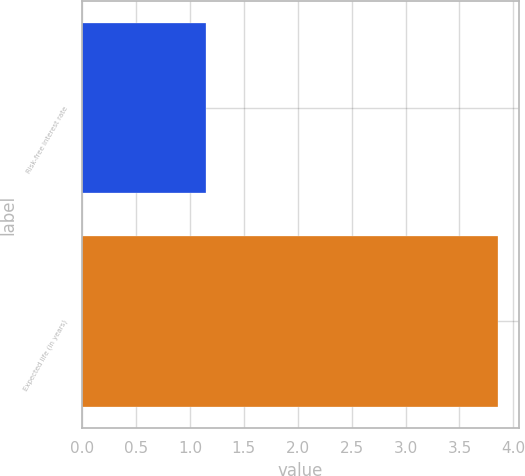Convert chart to OTSL. <chart><loc_0><loc_0><loc_500><loc_500><bar_chart><fcel>Risk-free interest rate<fcel>Expected life (in years)<nl><fcel>1.15<fcel>3.86<nl></chart> 